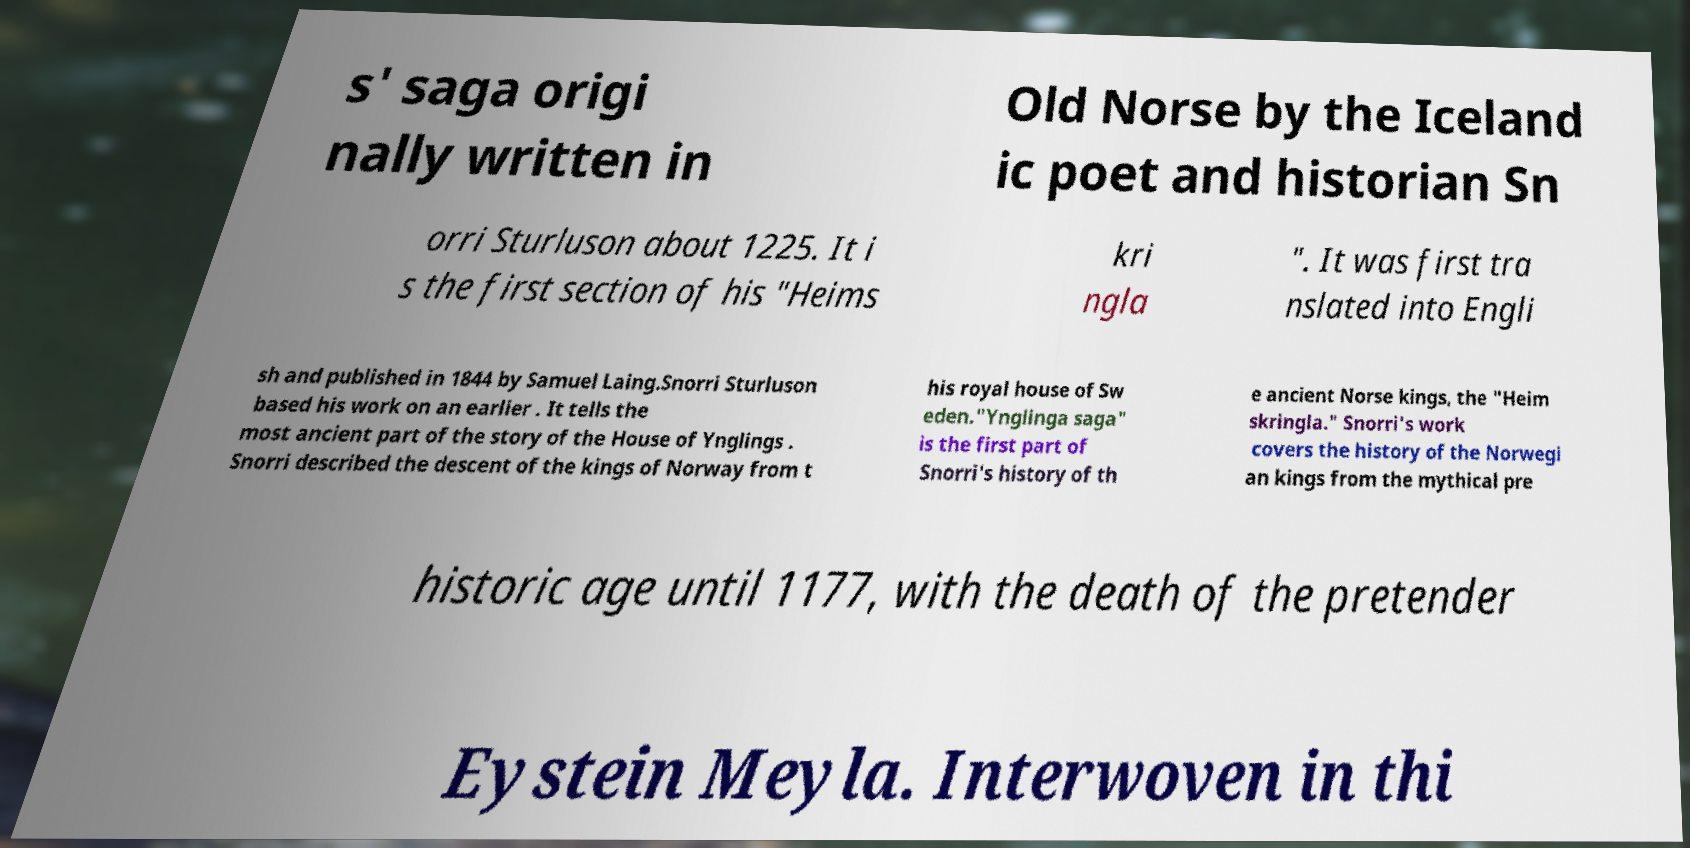Could you assist in decoding the text presented in this image and type it out clearly? s' saga origi nally written in Old Norse by the Iceland ic poet and historian Sn orri Sturluson about 1225. It i s the first section of his "Heims kri ngla ". It was first tra nslated into Engli sh and published in 1844 by Samuel Laing.Snorri Sturluson based his work on an earlier . It tells the most ancient part of the story of the House of Ynglings . Snorri described the descent of the kings of Norway from t his royal house of Sw eden."Ynglinga saga" is the first part of Snorri's history of th e ancient Norse kings, the "Heim skringla." Snorri's work covers the history of the Norwegi an kings from the mythical pre historic age until 1177, with the death of the pretender Eystein Meyla. Interwoven in thi 